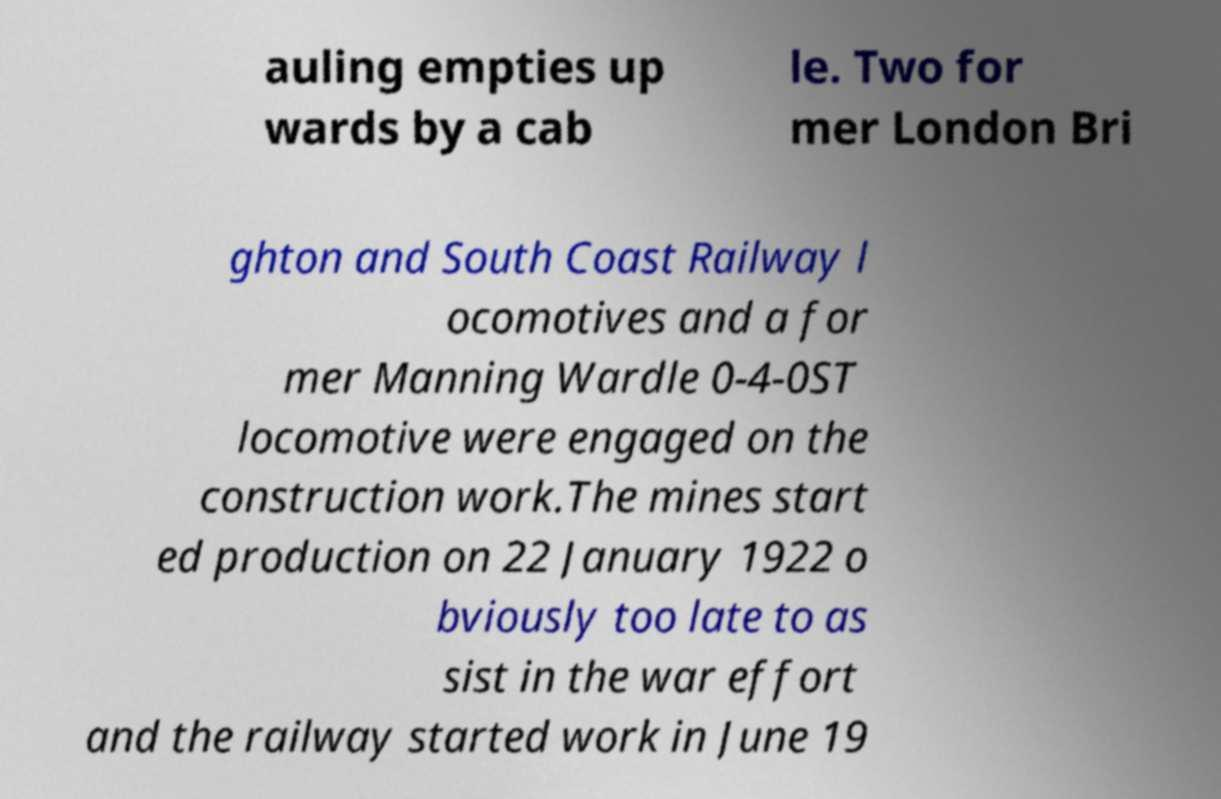Can you read and provide the text displayed in the image?This photo seems to have some interesting text. Can you extract and type it out for me? auling empties up wards by a cab le. Two for mer London Bri ghton and South Coast Railway l ocomotives and a for mer Manning Wardle 0-4-0ST locomotive were engaged on the construction work.The mines start ed production on 22 January 1922 o bviously too late to as sist in the war effort and the railway started work in June 19 